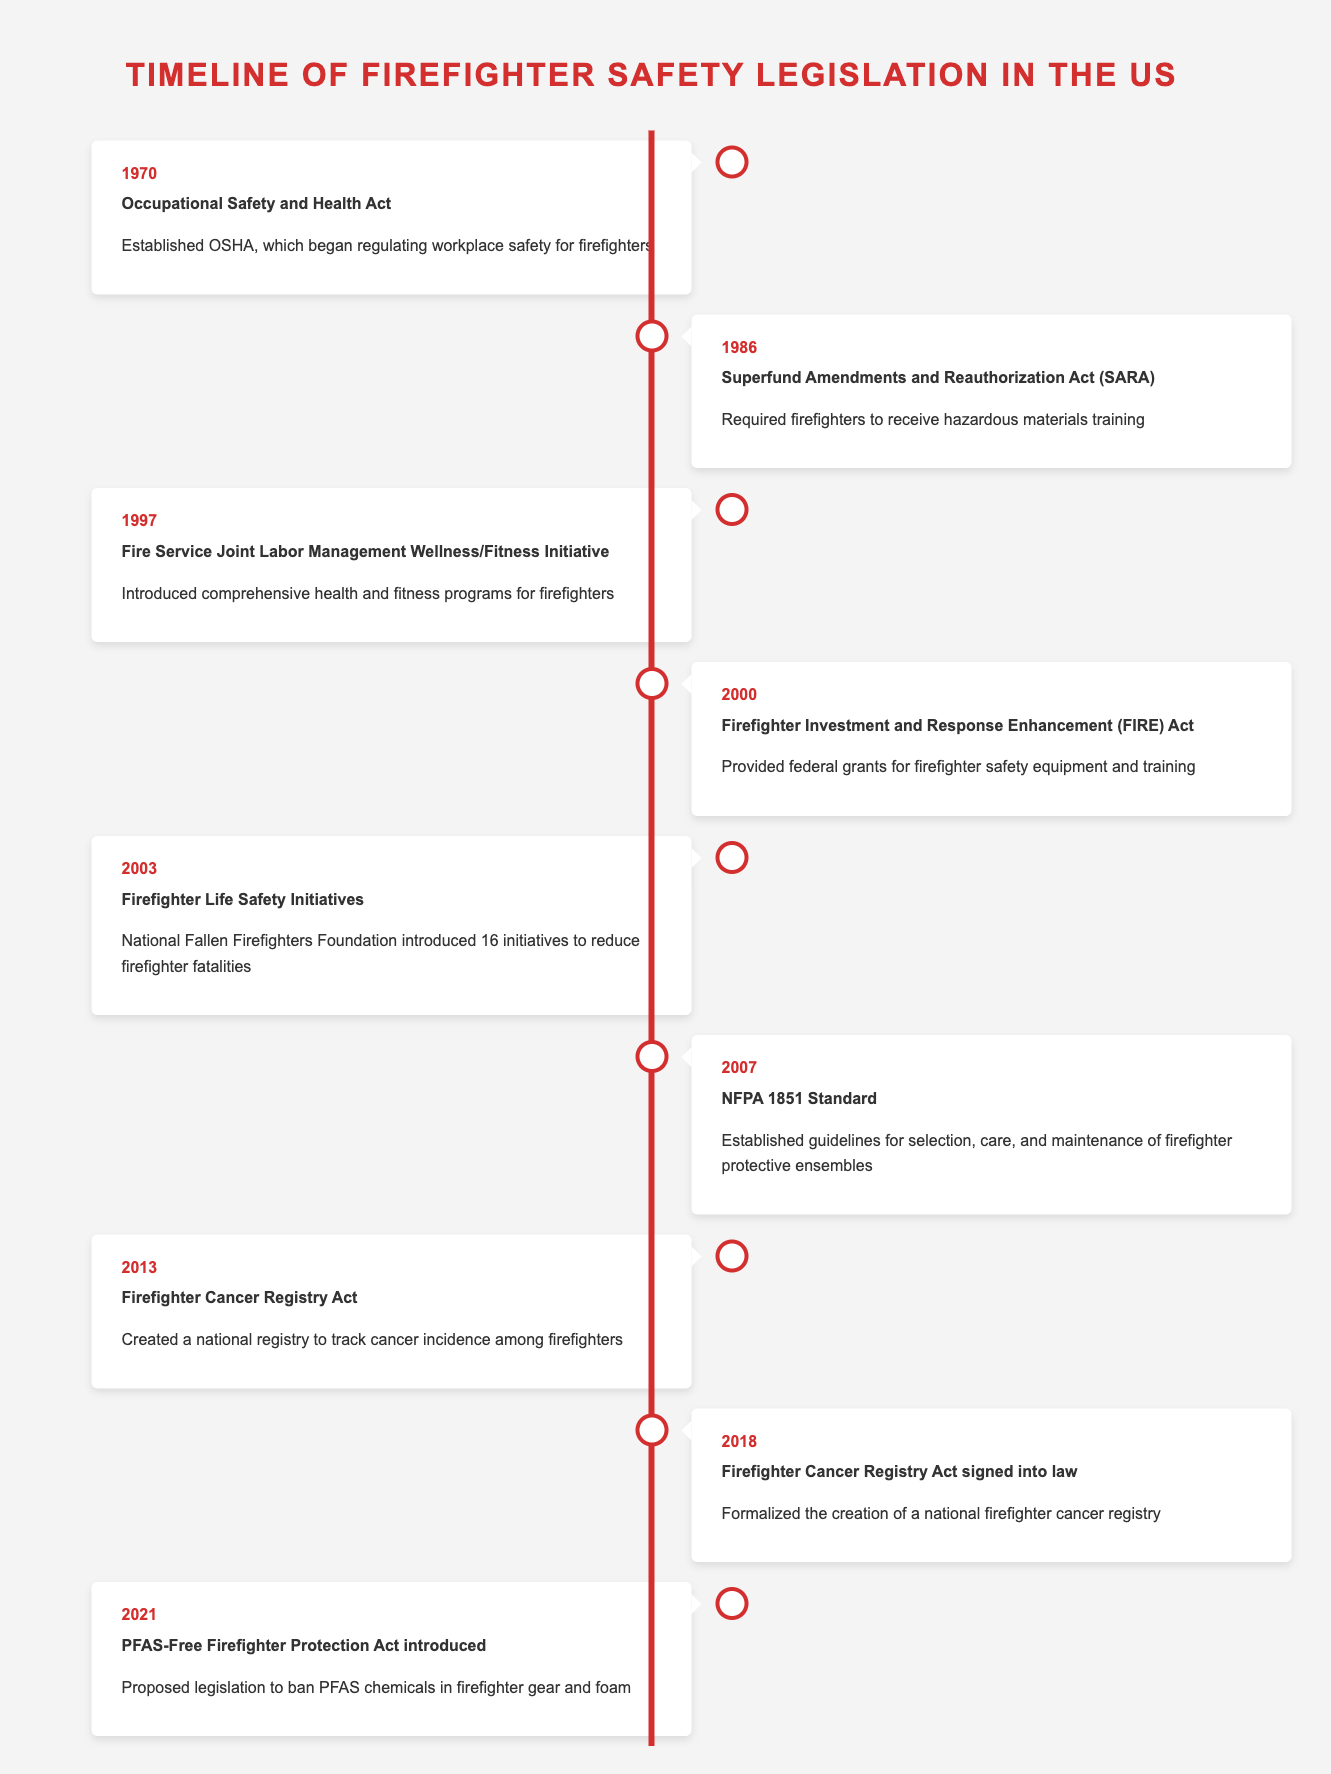What year did the Occupational Safety and Health Act get established? The timeline indicates that the Occupational Safety and Health Act was enacted in 1970.
Answer: 1970 How many significant legislations were introduced between 2000 and 2010? Looking at the timeline, we find the following laws during that period: the Firefighter Investment and Response Enhancement Act in 2000, the Firefighter Life Safety Initiatives in 2003, and the NFPA 1851 Standard in 2007, totaling three significant legislations.
Answer: 3 Was the Firefighter Cancer Registry Act signed into law before 2015? The Firefighter Cancer Registry Act was created in 2013, and it was signed into law in 2018, so it was established before 2015 but signed later.
Answer: Yes What is the difference in years between the establishment of the Fire Service Joint Labor Management Wellness/Fitness Initiative and the NFPA 1851 Standard? The Fire Service Joint Labor Management Wellness/Fitness Initiative was established in 1997, and the NFPA 1851 Standard was established in 2007. The difference is 2007 - 1997 = 10 years.
Answer: 10 years Did any legislation specifically address firefighter safety equipment funding? Yes, the Firefighter Investment and Response Enhancement Act in 2000 provided federal grants for firefighter safety equipment and training.
Answer: Yes What is the chronological order of the events related to firefighter safety from 1970 to 2021, based on the timeline? The events listed chronologically from 1970 to 2021 are: Occupational Safety and Health Act (1970), Superfund Amendments and Reauthorization Act (1986), Fire Service Joint Labor Management Wellness/Fitness Initiative (1997), Firefighter Investment and Response Enhancement Act (2000), Firefighter Life Safety Initiatives (2003), NFPA 1851 Standard (2007), Firefighter Cancer Registry Act (2013), Firefighter Cancer Registry Act signed into law (2018), PFAS-Free Firefighter Protection Act introduced (2021).
Answer: Occupational Safety and Health Act, Superfund Amendments and Reauthorization Act, Fire Service Joint Labor Management Wellness/Fitness Initiative, Firefighter Investment and Response Enhancement Act, Firefighter Life Safety Initiatives, NFPA 1851 Standard, Firefighter Cancer Registry Act, Firefighter Cancer Registry Act signed into law, PFAS-Free Firefighter Protection Act introduced In what year was legislation aimed at tracking firefighter cancer incidence created? The Firefighter Cancer Registry Act, which specifically aimed at tracking cancer incidence among firefighters, was created in the year 2013 according to the timeline.
Answer: 2013 